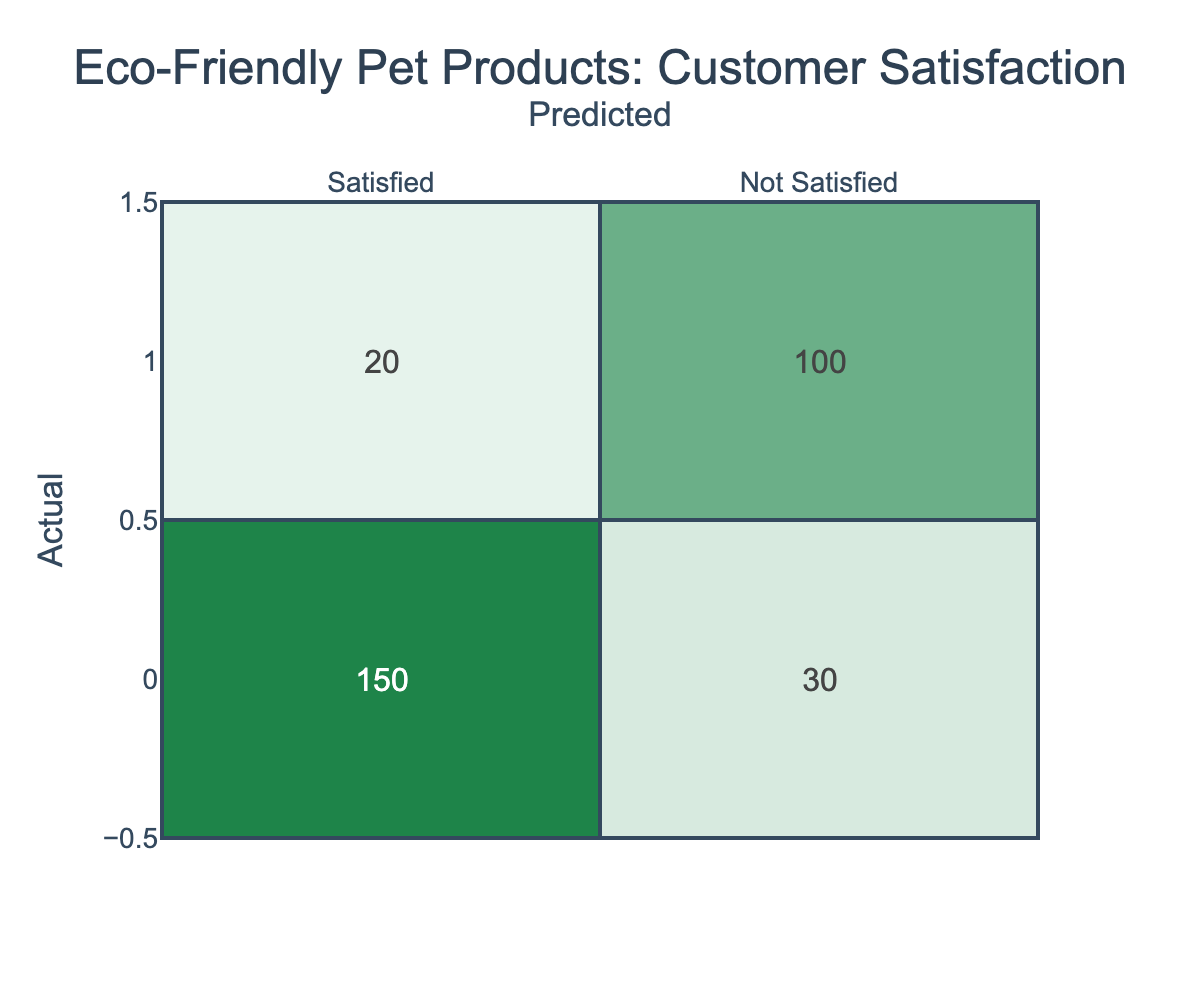What is the number of customers who were satisfied with eco-friendly pet products? The table indicates that 150 customers were predicted to be satisfied, which is found in the cell corresponding to "Satisfied" in the "Actual" row and "Satisfied" in the "Predicted" column.
Answer: 150 What percentage of customers predicted to be not satisfied were actually satisfied? The total number of customers predicted to be not satisfied is 30, and out of them, only 20 were actually not satisfied. The percentage of satisfied customers predicted as not satisfied is calculated as (30 / (20 + 30)) * 100 = 60%.
Answer: 60% How many customers were actually not satisfied with eco-friendly pet products? According to the table, the total number of customers marked as "Not Satisfied" is derived from the row labeled "Not Satisfied," which shows a count of 100.
Answer: 100 Is it true that the majority of customers who were predicted to be satisfied were actually satisfied? To assess this, we will compare the satisfied counts: 150 satisfied versus 30 not satisfied. Since 150 is greater than 30, it confirms that the majority of predicted satisfied customers were indeed satisfied.
Answer: Yes What is the ratio of customers who were satisfied to those who were not satisfied across all predictions? The sum of satisfied and not satisfied customers can be calculated: (150 + 30) satisfied and (20 + 100) not satisfied gives 180 satisfied and 120 not satisfied. The ratio is 180:120 which simplifies to 3:2.
Answer: 3:2 If 20 more customers had been predicted to be satisfied, what would the new total of satisfied customers be? With the original satisfied count being 150, adding 20 more predicted customers would result in a new count of 150 + 20 = 170 satisfied customers.
Answer: 170 What is the total number of customers surveyed? The total can be found by adding all the counts in the table: 150 + 30 + 20 + 100 = 300 total customers surveyed.
Answer: 300 What is the number of customers for whom the prediction was accurate (both satisfied and not satisfied)? The accurate predictions include those who were truly satisfied (150) and those who were truly not satisfied (100). Adding these gives: 150 + 100 = 250 accurate predictions.
Answer: 250 What is the difference between the number of actually satisfied customers and not satisfied customers? There are 150 actually satisfied customers and 100 not satisfied customers. The difference is calculated as 150 - 100 = 50.
Answer: 50 